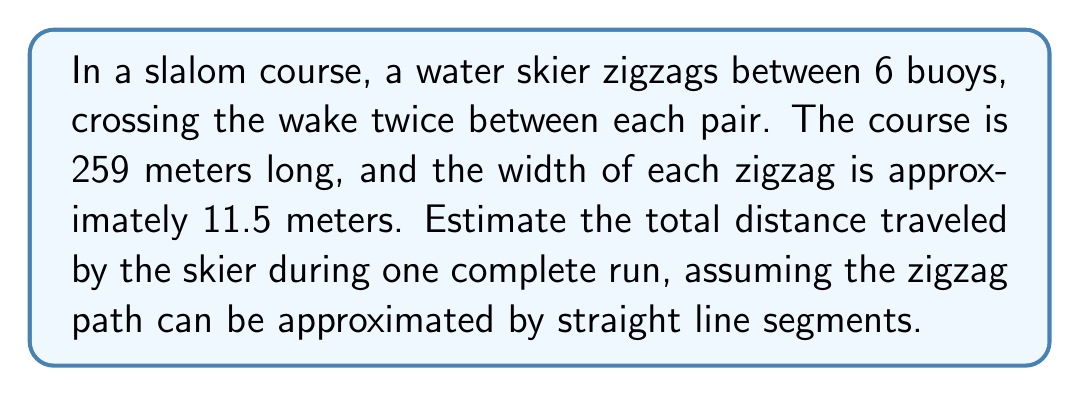Teach me how to tackle this problem. Let's approach this step-by-step:

1) First, we need to calculate the length of one zigzag segment. We can do this using the Pythagorean theorem:

   $$ \text{Segment length} = \sqrt{(\frac{259}{6})^2 + 11.5^2} $$

2) Simplify:
   $$ \text{Segment length} = \sqrt{(43.17)^2 + 11.5^2} = \sqrt{1863.6 + 132.25} = \sqrt{1995.85} \approx 44.67 \text{ meters} $$

3) There are 12 such segments in a complete run (6 buoys, 2 segments between each):

   $$ \text{Total distance} = 12 \times 44.67 = 536.04 \text{ meters} $$

4) To account for the slight curve of the skier's path and potential imperfections, we can round up to the nearest meter:

   $$ \text{Estimated total distance} \approx 537 \text{ meters} $$
Answer: $537 \text{ meters}$ 